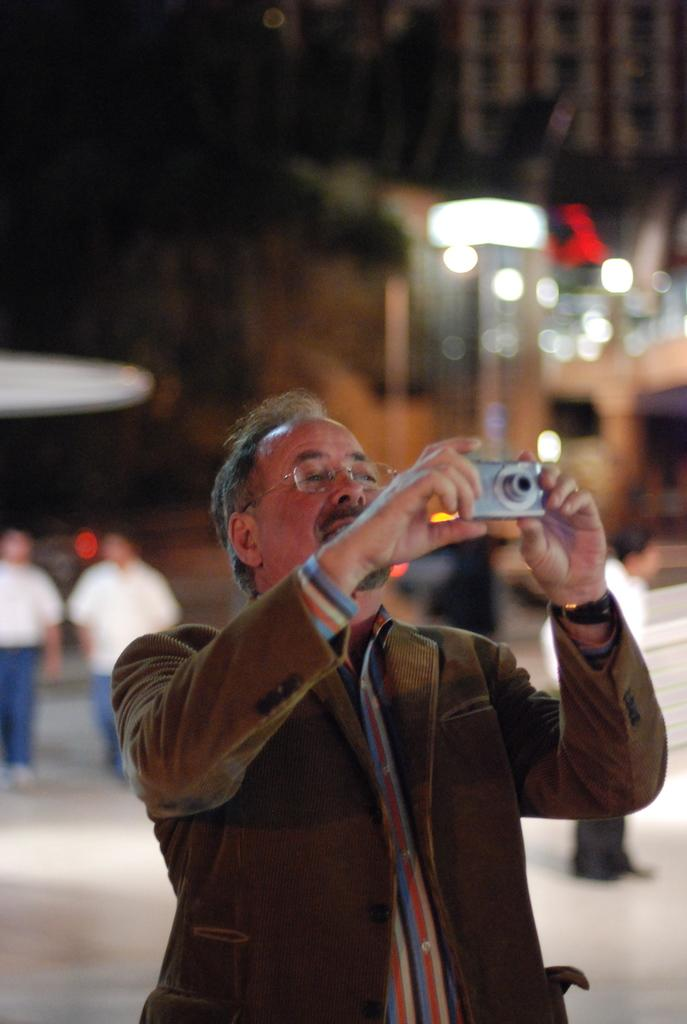Who is the main subject in the image? There is a man in the image. What is the man doing in the image? The man is taking a snap with a camera. Can you describe the background of the image? There are two persons standing in the background of the image. What else can be seen in the image? There are lights visible in the image. What type of flower is the fireman holding in the image? There is no fireman or flower present in the image. 